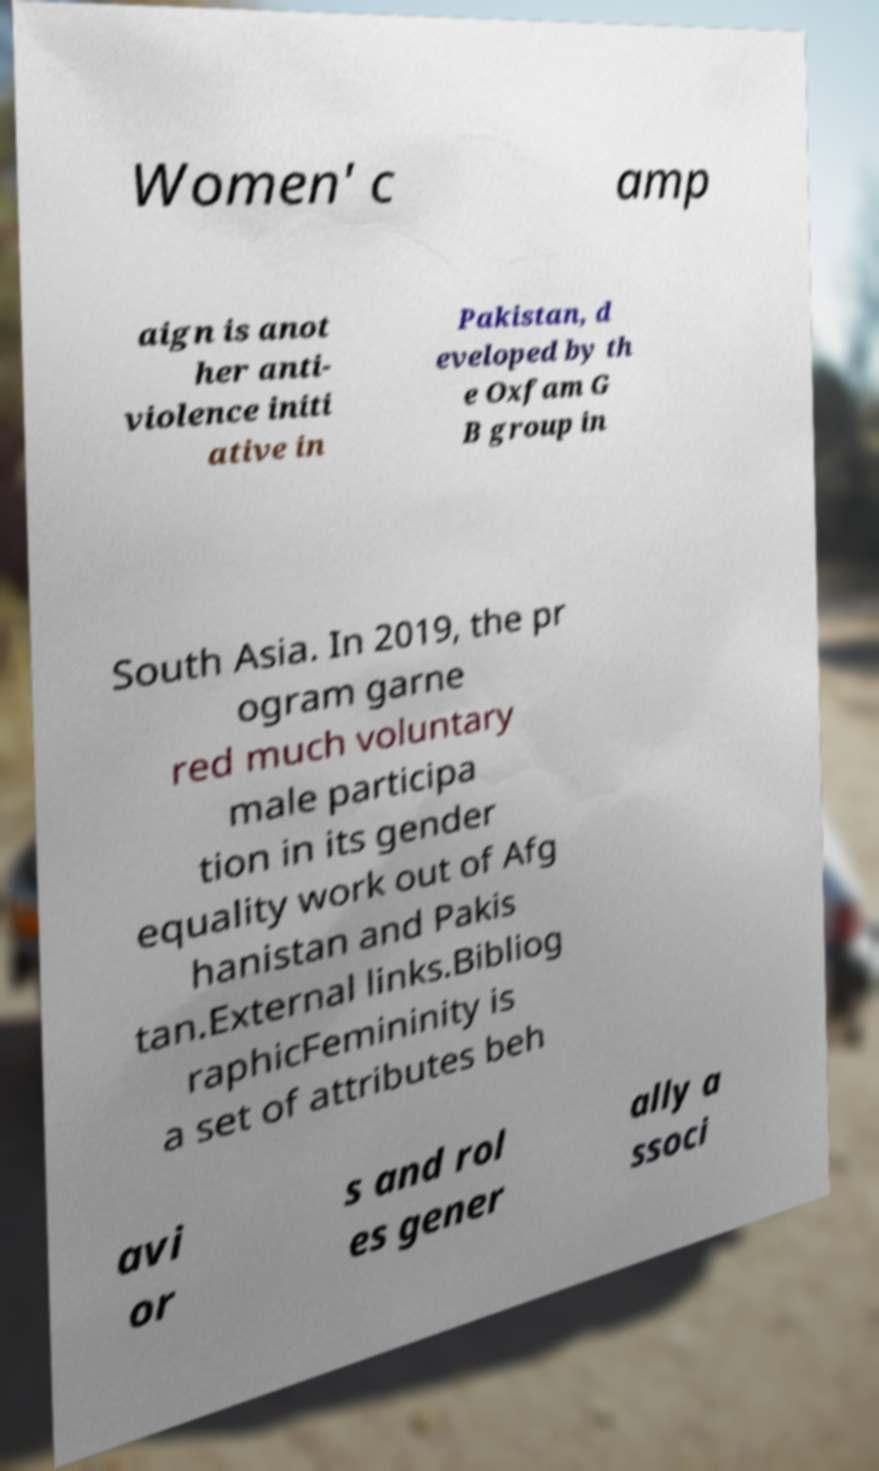I need the written content from this picture converted into text. Can you do that? Women' c amp aign is anot her anti- violence initi ative in Pakistan, d eveloped by th e Oxfam G B group in South Asia. In 2019, the pr ogram garne red much voluntary male participa tion in its gender equality work out of Afg hanistan and Pakis tan.External links.Bibliog raphicFemininity is a set of attributes beh avi or s and rol es gener ally a ssoci 